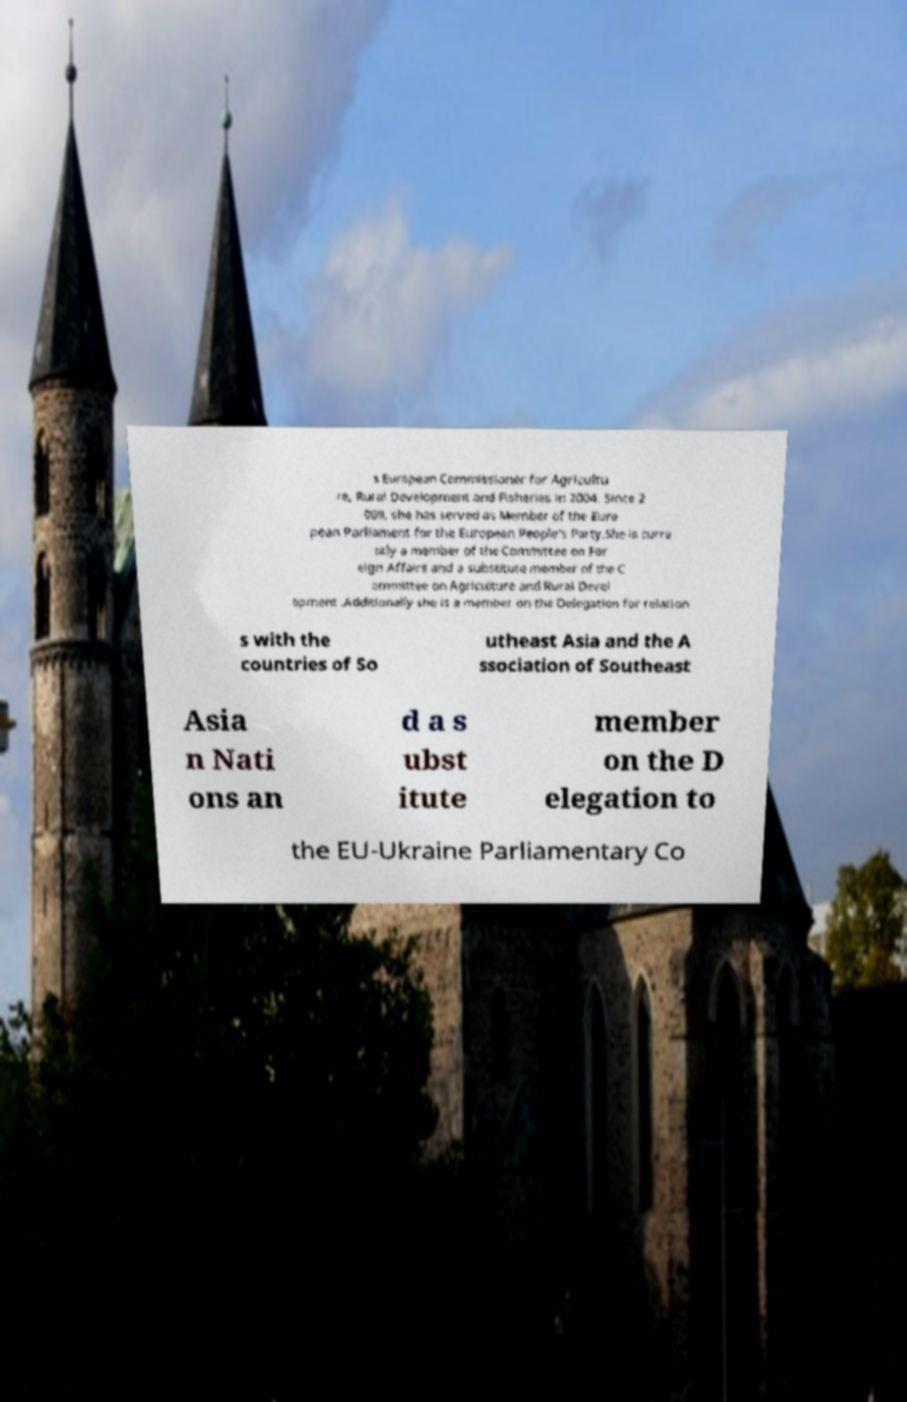I need the written content from this picture converted into text. Can you do that? s European Commissioner for Agricultu re, Rural Development and Fisheries in 2004. Since 2 009, she has served as Member of the Euro pean Parliament for the European People's Party.She is curre ntly a member of the Committee on For eign Affairs and a substitute member of the C ommittee on Agriculture and Rural Devel opment .Additionally she is a member on the Delegation for relation s with the countries of So utheast Asia and the A ssociation of Southeast Asia n Nati ons an d a s ubst itute member on the D elegation to the EU-Ukraine Parliamentary Co 